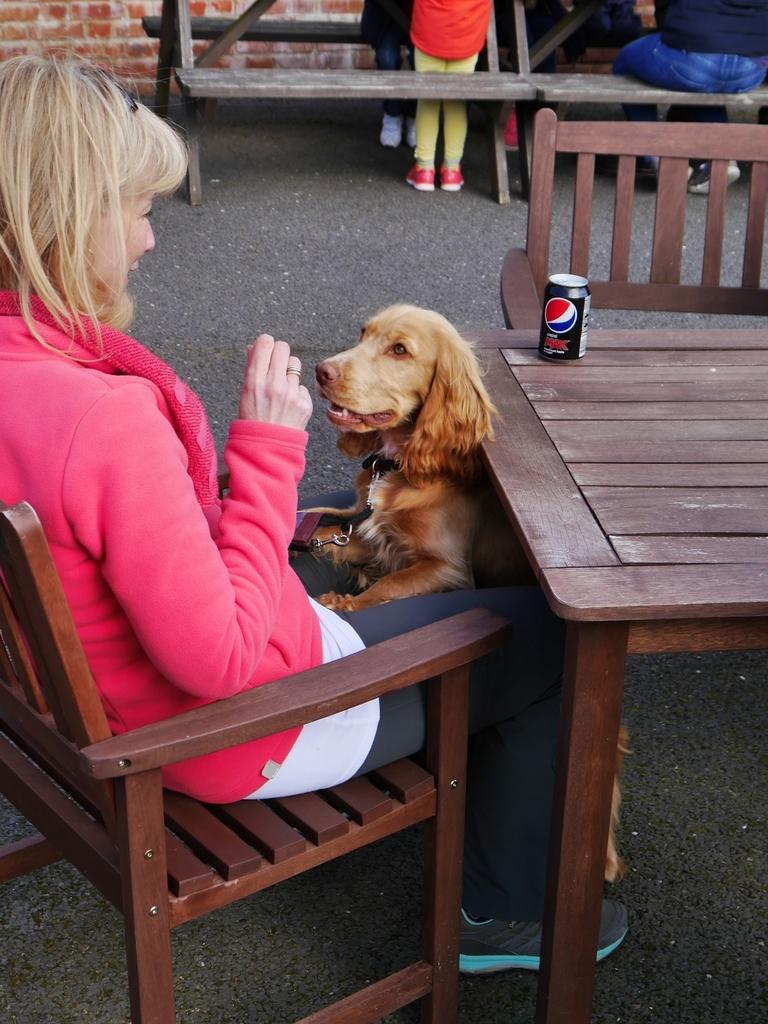Describe this image in one or two sentences. There is a woman sitting in chair and dog in front of her and a coke tin in table. 